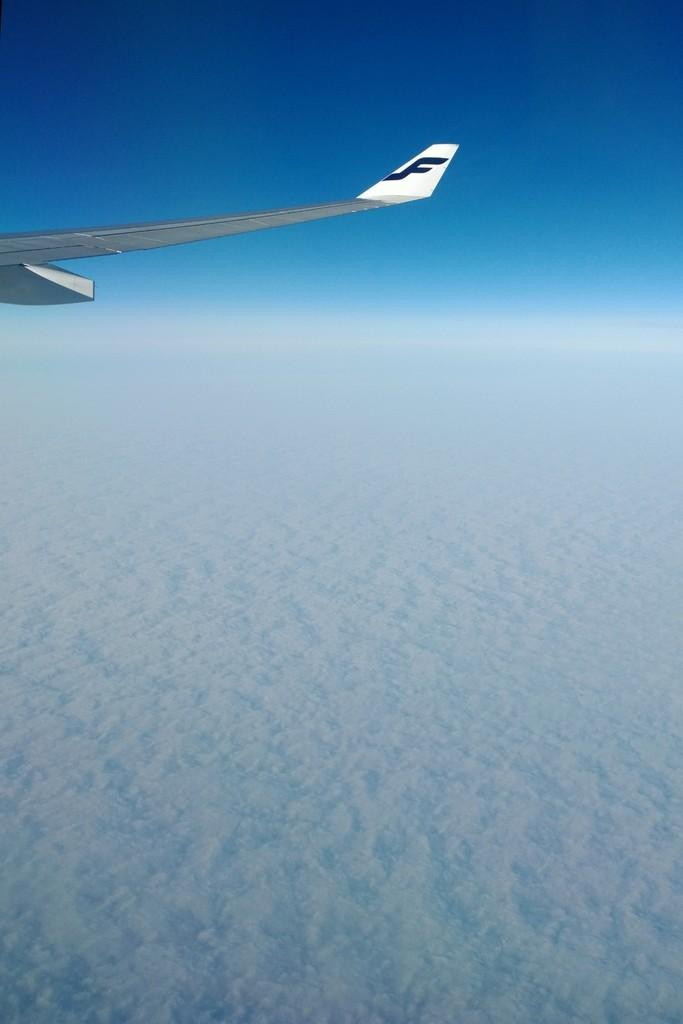What is the main subject of the picture? The main subject of the picture is a wing of an airplane. What can be seen in the sky in the picture? Clouds and the sky are visible in the picture. What type of prison can be seen in the image? There is no prison present in the image; it features a wing of an airplane and clouds in the sky. How many balls are visible in the image? There are no balls present in the image. 